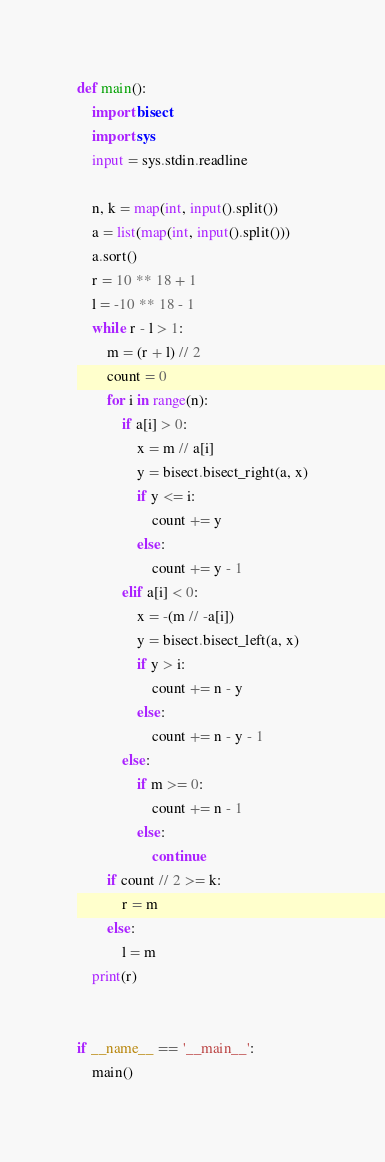Convert code to text. <code><loc_0><loc_0><loc_500><loc_500><_Python_>def main():
    import bisect
    import sys
    input = sys.stdin.readline

    n, k = map(int, input().split())
    a = list(map(int, input().split()))
    a.sort()
    r = 10 ** 18 + 1
    l = -10 ** 18 - 1
    while r - l > 1:
        m = (r + l) // 2
        count = 0
        for i in range(n):
            if a[i] > 0:
                x = m // a[i]
                y = bisect.bisect_right(a, x)
                if y <= i:
                    count += y
                else:
                    count += y - 1
            elif a[i] < 0:
                x = -(m // -a[i])
                y = bisect.bisect_left(a, x)
                if y > i:
                    count += n - y
                else:
                    count += n - y - 1
            else:
                if m >= 0:
                    count += n - 1
                else:
                    continue
        if count // 2 >= k:
            r = m
        else:
            l = m
    print(r)


if __name__ == '__main__':
    main()</code> 